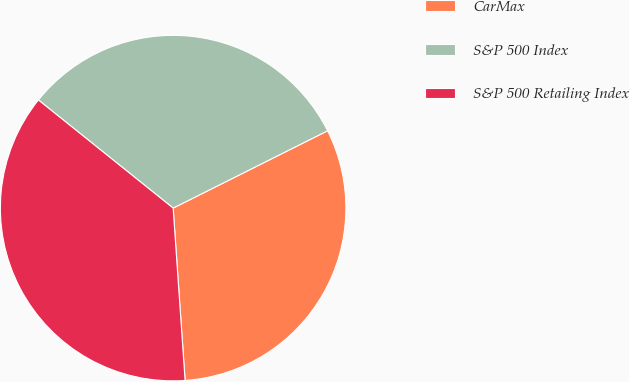Convert chart to OTSL. <chart><loc_0><loc_0><loc_500><loc_500><pie_chart><fcel>CarMax<fcel>S&P 500 Index<fcel>S&P 500 Retailing Index<nl><fcel>31.29%<fcel>31.85%<fcel>36.87%<nl></chart> 